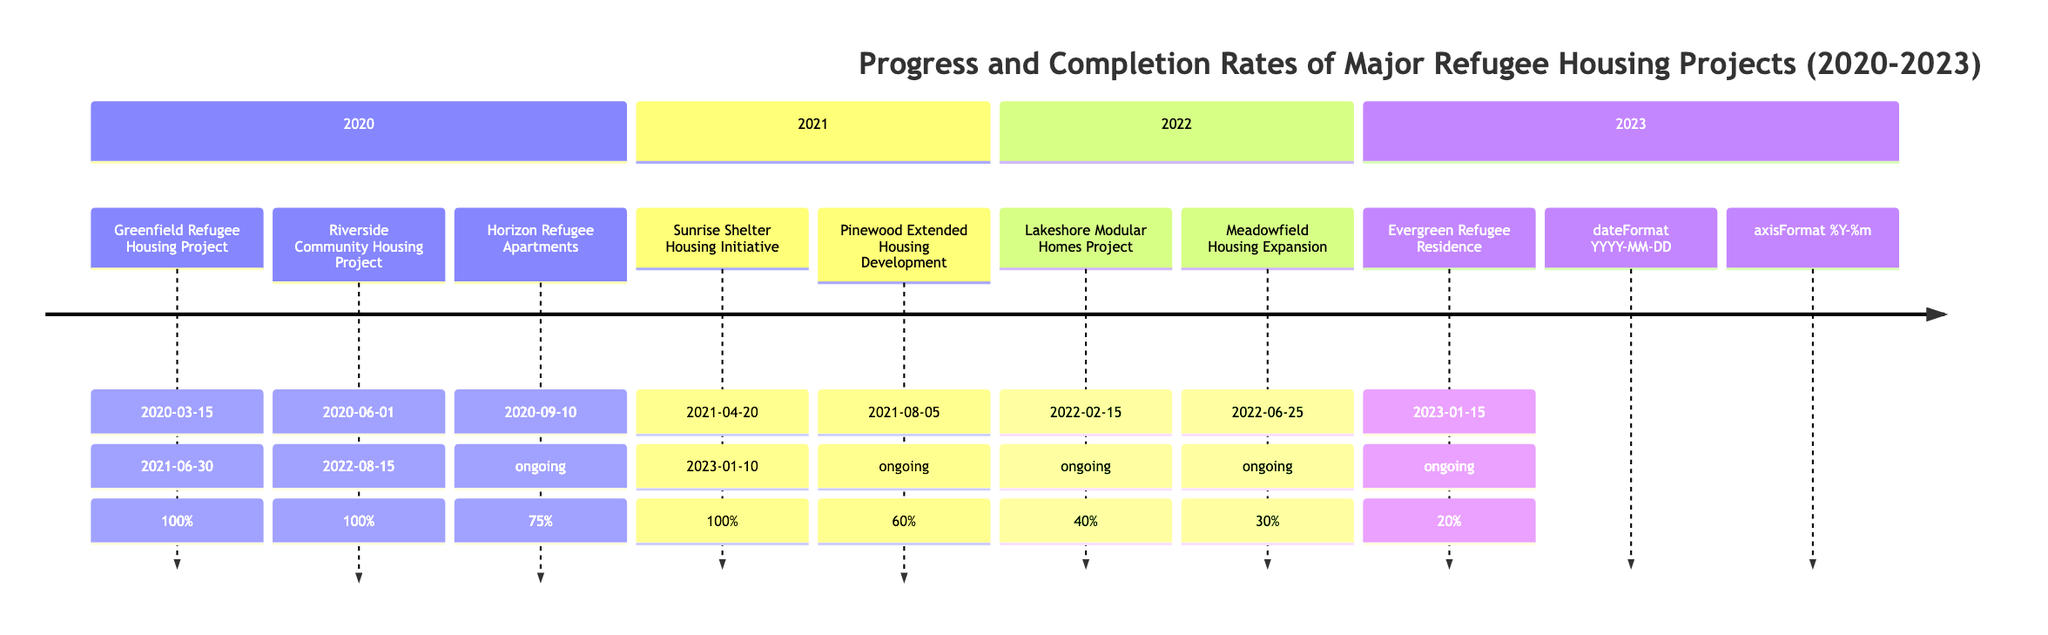What is the status of the Greenfield Refugee Housing Project? The status indicates that the Greenfield Refugee Housing Project is marked as "Completed," indicating that all planned activities have been finished as of its completion date, June 30, 2021.
Answer: Completed In which year did the Evergreen Refugee Residence start? The Evergreen Refugee Residence project started on January 15, 2023, which is derived from the timeline that lists all projects by start dates year by year.
Answer: 2023 How many projects were ongoing in 2022? By reviewing the timeline for the year 2022, there are two ongoing projects listed: Lakeshore Modular Homes Project (40% progress) and Meadowfield Housing Expansion (30% progress).
Answer: 2 What is the completion date for the Sunrise Shelter Housing Initiative? The completion date for the Sunrise Shelter Housing Initiative is shown to be January 10, 2023, provided in the details for that project within the timeline for 2021.
Answer: 2023-01-10 Which project had the highest completion percentage in 2021? Upon examining the list of projects for 2021, the highest completion percentage is 100%, achieved by the Sunrise Shelter Housing Initiative, indicating it is fully finished.
Answer: 100% What is the progress percentage of the Horizon Refugee Apartments? The Horizon Refugee Apartments is listed with a progress percentage of 75%, stating how much of the project was completed up to the current date of the timeline.
Answer: 75% Which project began in 2022 has the lowest progress? The Meadowfield Housing Expansion started in June 2022 with a progress of 30%, which is less compared to Lakeshore Modular Homes Project at 40%. This makes Meadowfield the project with the lowest progress among the ongoing projects from that year.
Answer: Meadowfield Housing Expansion What is the total number of projects listed in 2020? The timeline specifies that there were three projects listed in 2020: Greenfield Refugee Housing Project, Riverside Community Housing Project, and Horizon Refugee Apartments, which can be counted directly from that section of the timeline.
Answer: 3 What percentage of the Pinewood Extended Housing Development is complete? The Pinewood Extended Housing Development is noted with a completion percentage of 60%, which indicates the amount of work that has been accomplished on this project so far.
Answer: 60% 